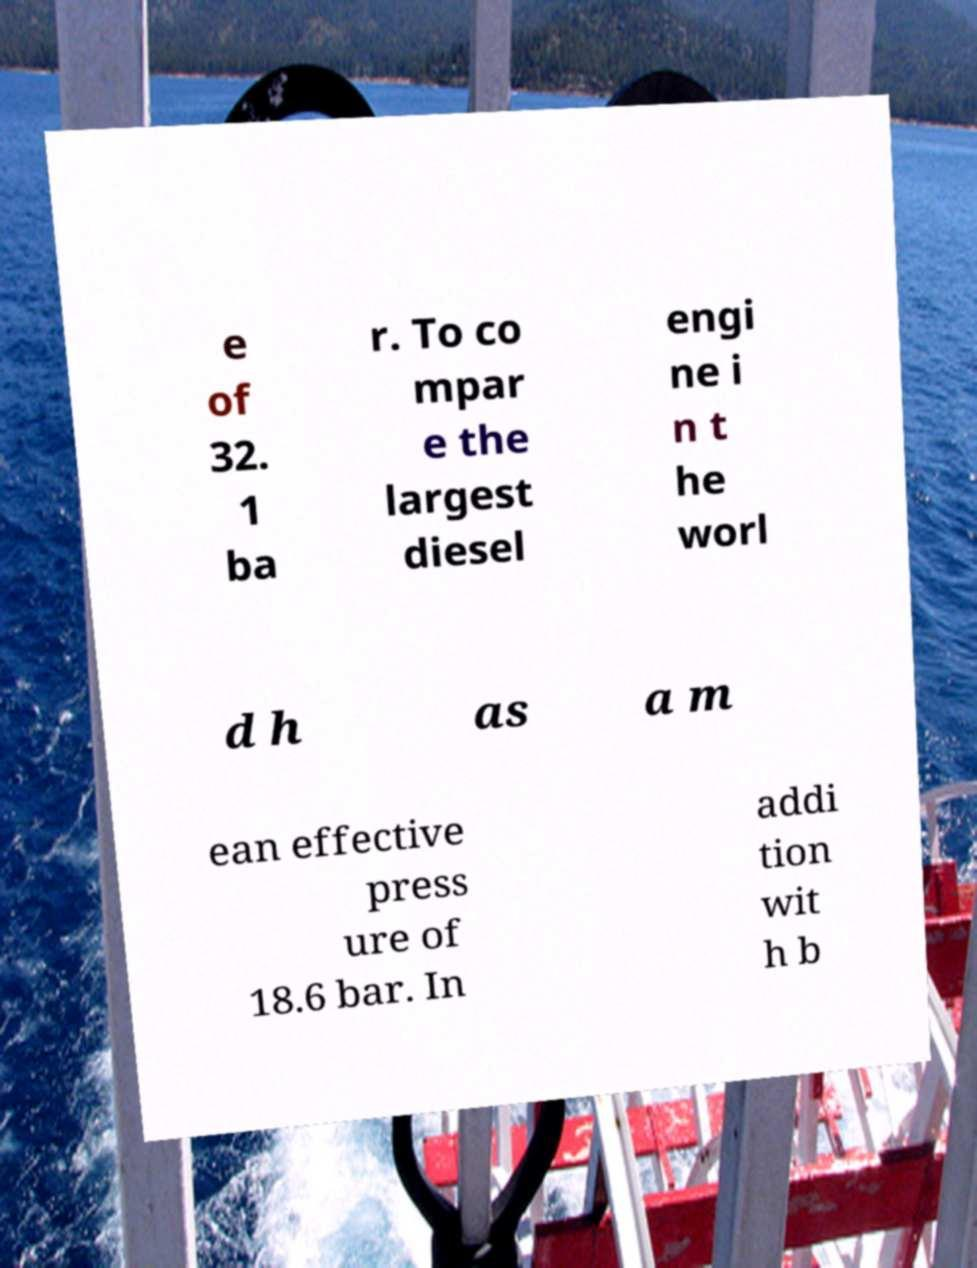Can you read and provide the text displayed in the image?This photo seems to have some interesting text. Can you extract and type it out for me? e of 32. 1 ba r. To co mpar e the largest diesel engi ne i n t he worl d h as a m ean effective press ure of 18.6 bar. In addi tion wit h b 